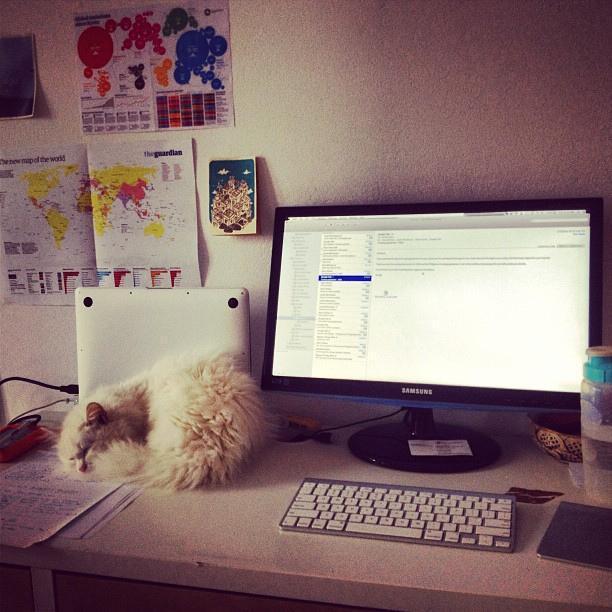How many animals are in the picture?
Give a very brief answer. 1. How many monitors do you see?
Give a very brief answer. 1. How many tvs are visible?
Give a very brief answer. 1. How many bowls are there?
Give a very brief answer. 1. How many wooden chairs are there?
Give a very brief answer. 0. 